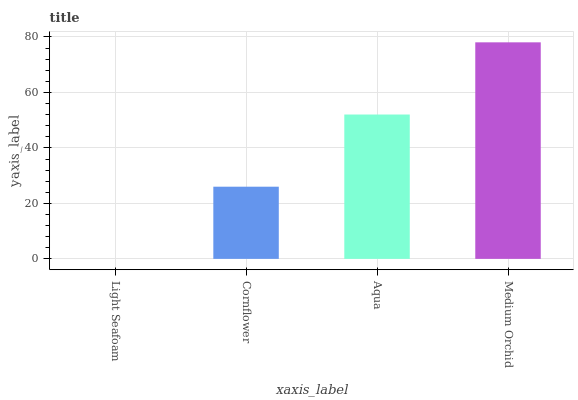Is Light Seafoam the minimum?
Answer yes or no. Yes. Is Medium Orchid the maximum?
Answer yes or no. Yes. Is Cornflower the minimum?
Answer yes or no. No. Is Cornflower the maximum?
Answer yes or no. No. Is Cornflower greater than Light Seafoam?
Answer yes or no. Yes. Is Light Seafoam less than Cornflower?
Answer yes or no. Yes. Is Light Seafoam greater than Cornflower?
Answer yes or no. No. Is Cornflower less than Light Seafoam?
Answer yes or no. No. Is Aqua the high median?
Answer yes or no. Yes. Is Cornflower the low median?
Answer yes or no. Yes. Is Light Seafoam the high median?
Answer yes or no. No. Is Medium Orchid the low median?
Answer yes or no. No. 